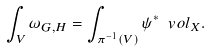<formula> <loc_0><loc_0><loc_500><loc_500>\int _ { V } \omega _ { G , H } = \int _ { \pi ^ { - 1 } ( V ) } \psi ^ { * } \ v o l _ { X } .</formula> 